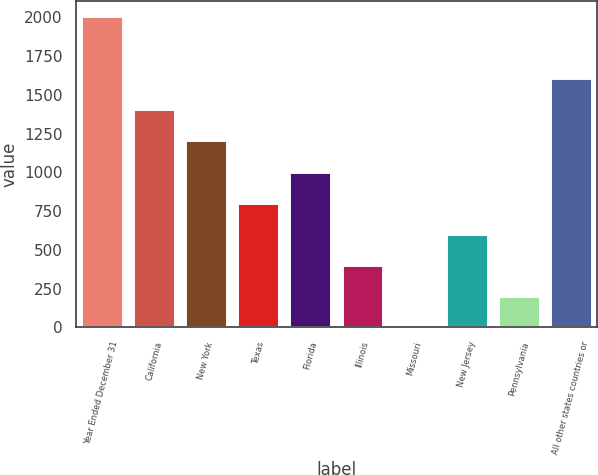Convert chart. <chart><loc_0><loc_0><loc_500><loc_500><bar_chart><fcel>Year Ended December 31<fcel>California<fcel>New York<fcel>Texas<fcel>Florida<fcel>Illinois<fcel>Missouri<fcel>New Jersey<fcel>Pennsylvania<fcel>All other states countries or<nl><fcel>2008<fcel>1406.53<fcel>1206.04<fcel>805.06<fcel>1005.55<fcel>404.08<fcel>3.1<fcel>604.57<fcel>203.59<fcel>1607.02<nl></chart> 